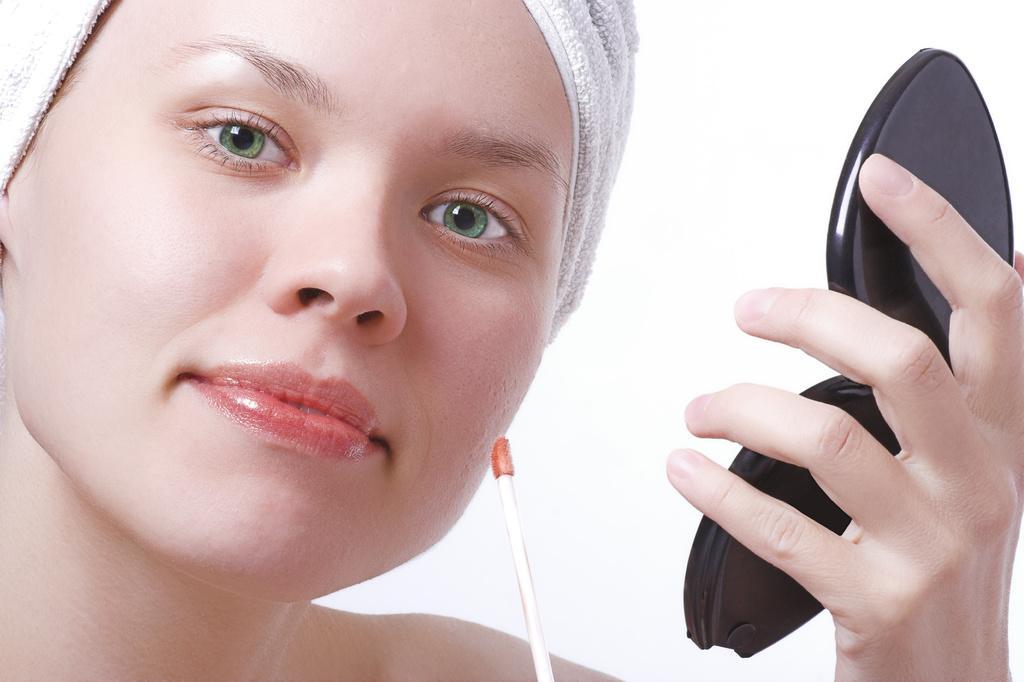Could you give a brief overview of what you see in this image? In this image I can see a woman wearing a cloth to her head and holding a black colored object in her hand. I can see the white colored background. 